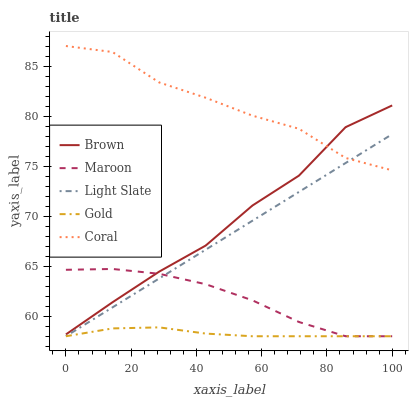Does Gold have the minimum area under the curve?
Answer yes or no. Yes. Does Coral have the maximum area under the curve?
Answer yes or no. Yes. Does Brown have the minimum area under the curve?
Answer yes or no. No. Does Brown have the maximum area under the curve?
Answer yes or no. No. Is Light Slate the smoothest?
Answer yes or no. Yes. Is Coral the roughest?
Answer yes or no. Yes. Is Brown the smoothest?
Answer yes or no. No. Is Brown the roughest?
Answer yes or no. No. Does Light Slate have the lowest value?
Answer yes or no. Yes. Does Brown have the lowest value?
Answer yes or no. No. Does Coral have the highest value?
Answer yes or no. Yes. Does Brown have the highest value?
Answer yes or no. No. Is Maroon less than Coral?
Answer yes or no. Yes. Is Coral greater than Maroon?
Answer yes or no. Yes. Does Brown intersect Coral?
Answer yes or no. Yes. Is Brown less than Coral?
Answer yes or no. No. Is Brown greater than Coral?
Answer yes or no. No. Does Maroon intersect Coral?
Answer yes or no. No. 